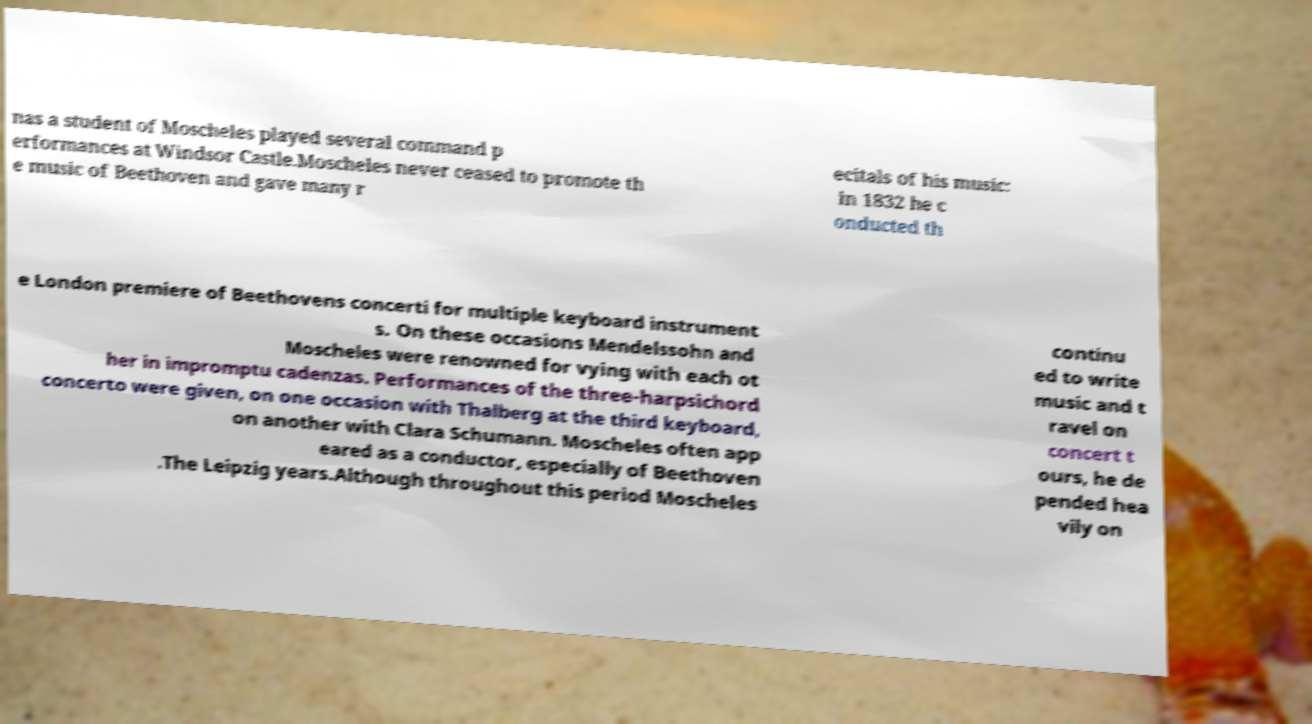Could you extract and type out the text from this image? nas a student of Moscheles played several command p erformances at Windsor Castle.Moscheles never ceased to promote th e music of Beethoven and gave many r ecitals of his music: in 1832 he c onducted th e London premiere of Beethovens concerti for multiple keyboard instrument s. On these occasions Mendelssohn and Moscheles were renowned for vying with each ot her in impromptu cadenzas. Performances of the three-harpsichord concerto were given, on one occasion with Thalberg at the third keyboard, on another with Clara Schumann. Moscheles often app eared as a conductor, especially of Beethoven .The Leipzig years.Although throughout this period Moscheles continu ed to write music and t ravel on concert t ours, he de pended hea vily on 